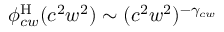<formula> <loc_0><loc_0><loc_500><loc_500>\phi _ { c w } ^ { H } ( c ^ { 2 } w ^ { 2 } ) \sim ( c ^ { 2 } w ^ { 2 } ) ^ { - \gamma _ { c w } }</formula> 